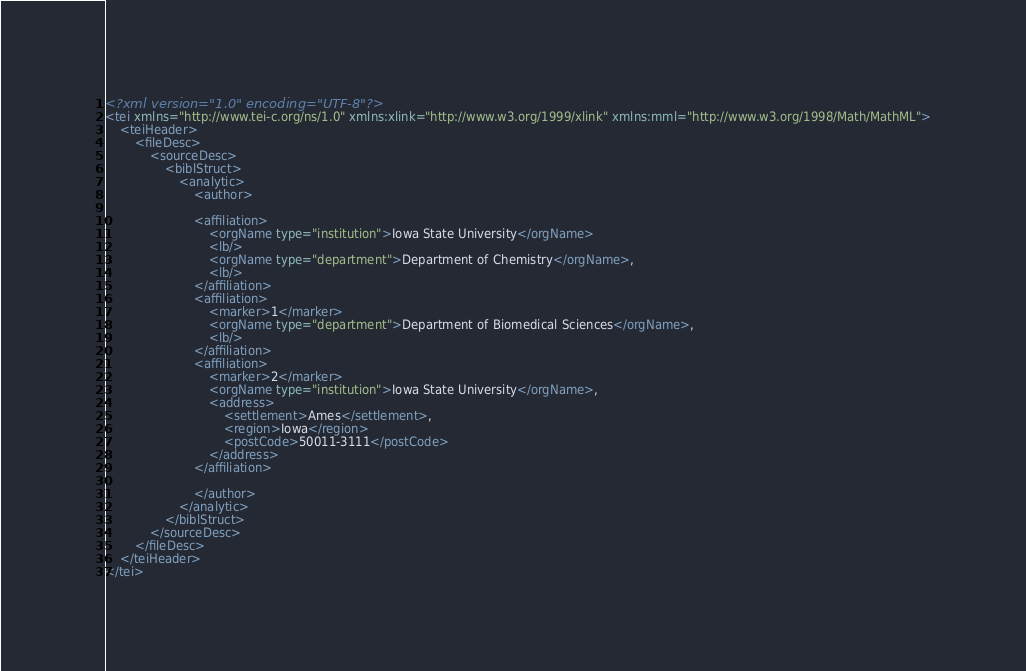<code> <loc_0><loc_0><loc_500><loc_500><_XML_><?xml version="1.0" encoding="UTF-8"?>
<tei xmlns="http://www.tei-c.org/ns/1.0" xmlns:xlink="http://www.w3.org/1999/xlink" xmlns:mml="http://www.w3.org/1998/Math/MathML">
	<teiHeader>
		<fileDesc>
			<sourceDesc>
				<biblStruct>
					<analytic>
						<author>

						<affiliation>
							<orgName type="institution">Iowa State University</orgName>
							<lb/>
							<orgName type="department">Department of Chemistry</orgName>,
							<lb/>
						</affiliation>
						<affiliation>
							<marker>1</marker>
							<orgName type="department">Department of Biomedical Sciences</orgName>,
							<lb/>
						</affiliation>
						<affiliation>
							<marker>2</marker>
							<orgName type="institution">Iowa State University</orgName>,
							<address>
								<settlement>Ames</settlement>,
								<region>Iowa</region>
								<postCode>50011-3111</postCode>
							</address>
						</affiliation>

						</author>
					</analytic>
				</biblStruct>
			</sourceDesc>
		</fileDesc>
	</teiHeader>
</tei>
</code> 